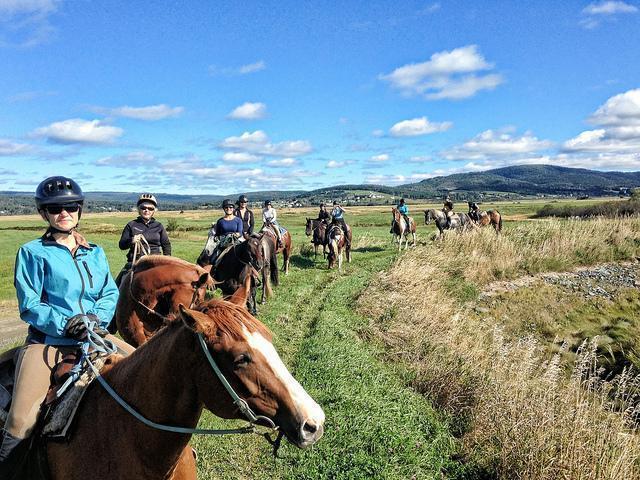What do these horseback riders ride along?
Make your selection from the four choices given to correctly answer the question.
Options: Desert, ocean, city, streambed. Streambed. 